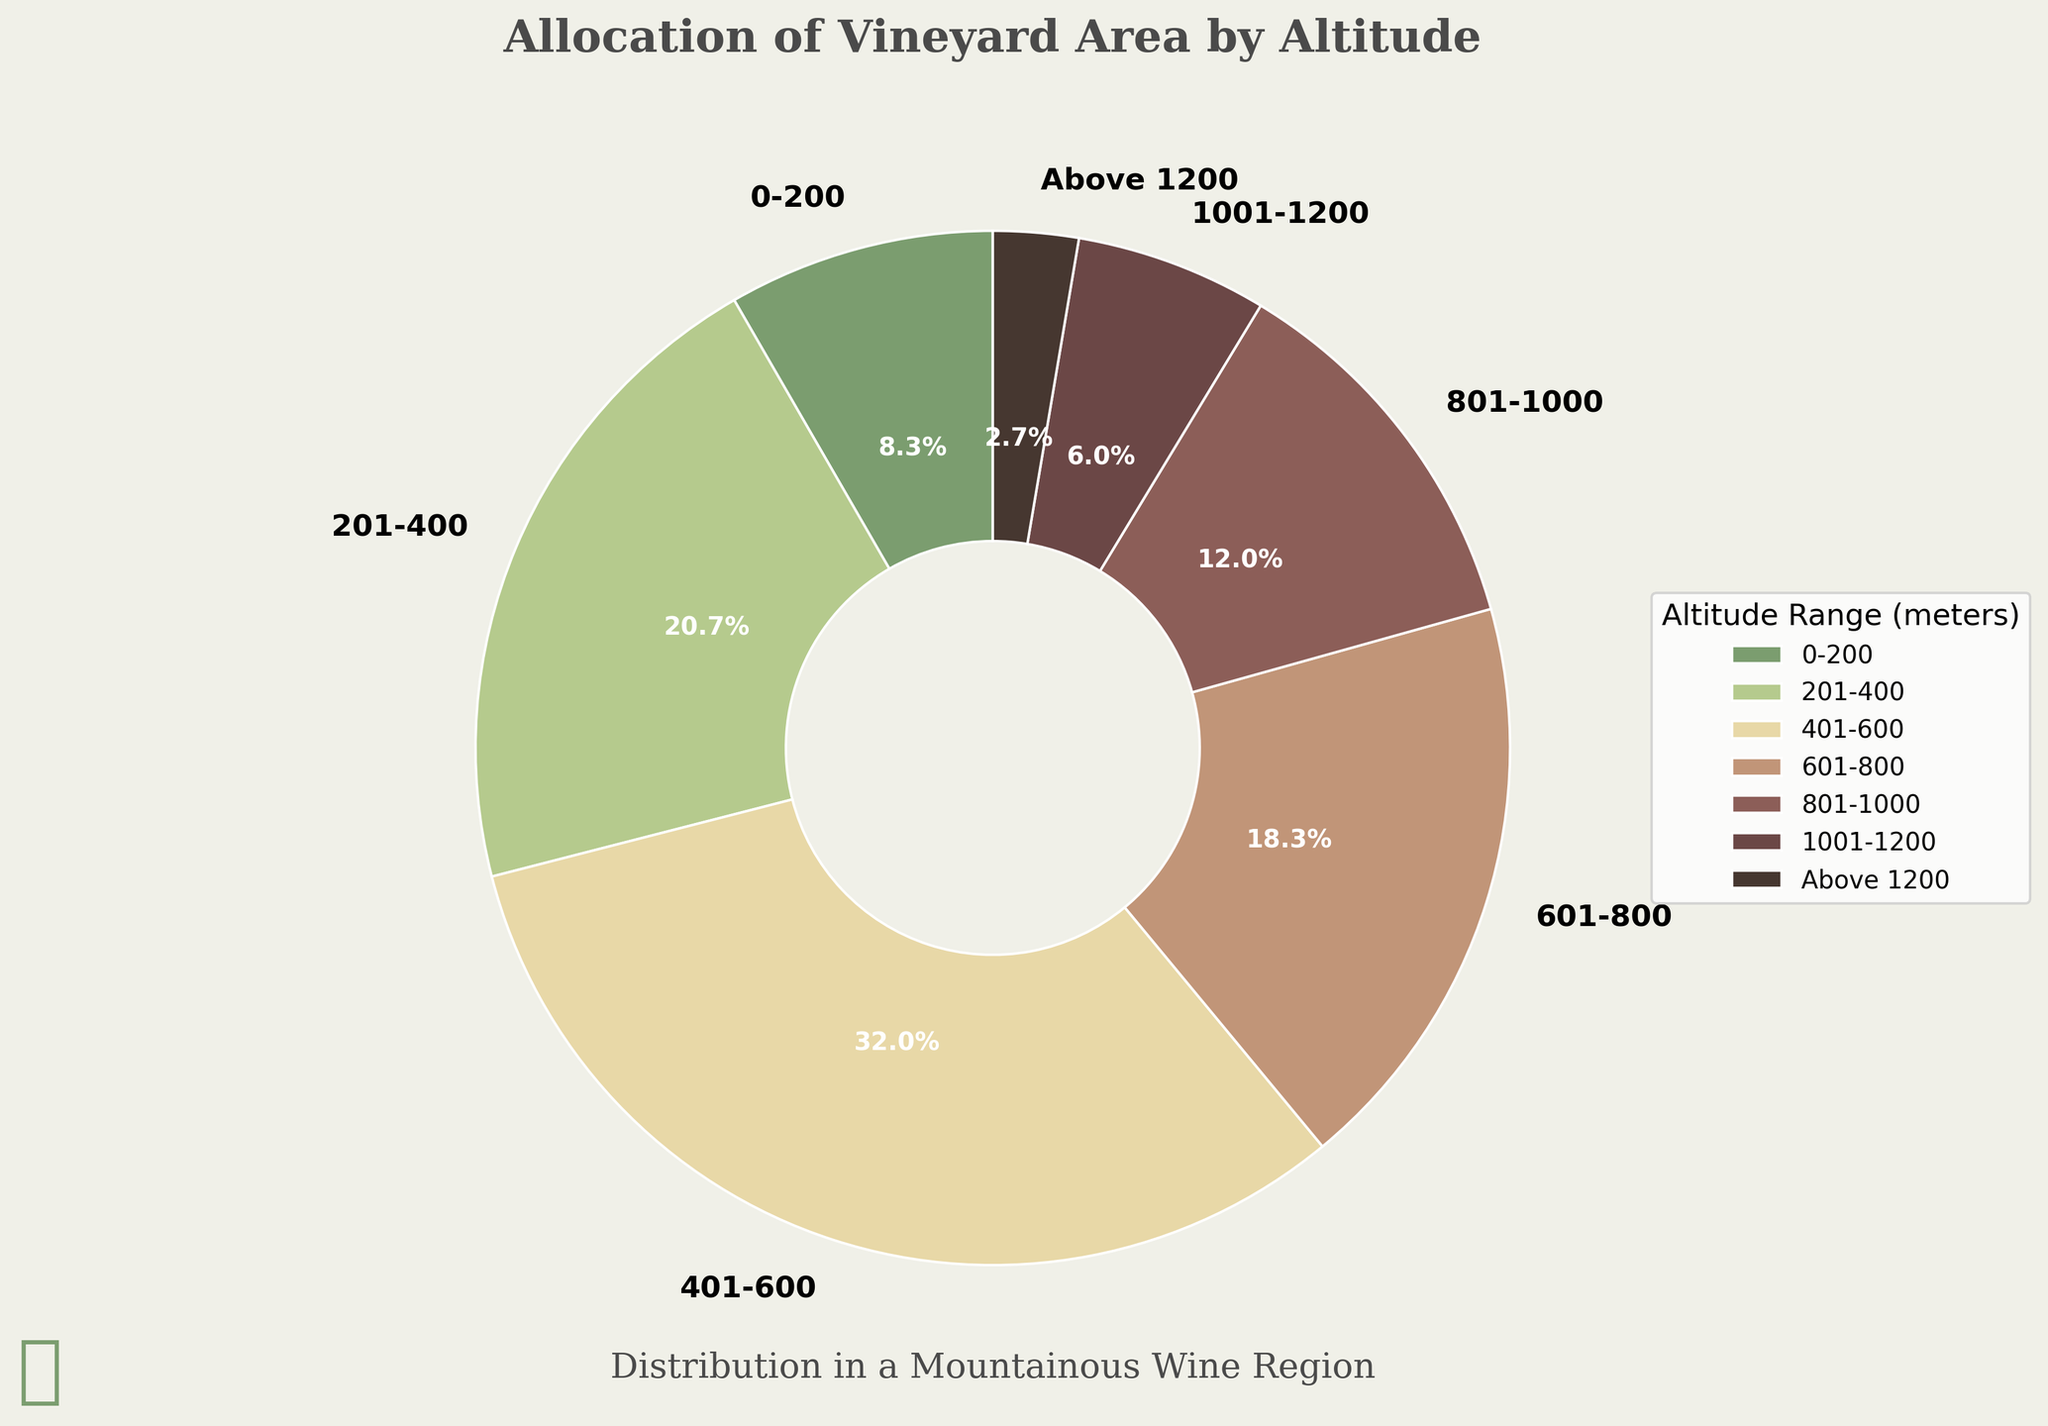What is the overall trend in the allocation of vineyard area by altitude? The trend shows that the vineyard area generally increases with altitude from 0-200 meters to 401-600 meters, reaching a peak at 401-600 meters, then gradually decreases as altitude increases beyond 600 meters. The largest area is between 401-600 meters while the smallest area is above 1200 meters.
Answer: The vineyard area initially increases with altitude, peaks at 401-600 meters, then decreases as altitude increases Which altitude range has the largest vineyard area? By inspecting the pie chart, the slice corresponding to the 401-600 meters altitude range is the largest indicating the highest vineyard area percentage. It is labeled with the percentage value.
Answer: 401-600 meters What percentage of the vineyard area is found above 1000 meters? From the chart, the segments for 1001-1200 meters and above 1200 meters are labeled with their percentage values: 8.4% and 3.8% respectively. Summing these gives 8.4% + 3.8%.
Answer: 12.2% How does the vineyard area between 601-800 meters compare to the area between 801-1000 meters? The pie chart shows that the 601-800 meters range has a larger slice compared to the 801-1000 meters range. Referring to their percentage labels, 601-800 meters is larger.
Answer: 601-800 meters is larger What is the combined vineyard area for altitudes up to 400 meters? Adding up the labeled percentages for 0-200 meters and 201-400 meters from the pie chart: 12% + 29.7%.
Answer: 41.7% Which altitude range occupies the smallest percentage of vineyard area? The smallest percentage slice in the pie chart is labeled for the "Above 1200 meters" range.
Answer: Above 1200 meters What's the ratio of vineyard area between 401-600 meters and 1001-1200 meters? From the pie chart, the percentages for these ranges are labeled as 45.9% for 401-600 meters and 8.4% for 1001-1200 meters. The ratio is 45.9% / 8.4%.
Answer: 5.46:1 How do the vineyard areas between altitudes 0-200 meters and 201-400 meters compare visually in the pie chart? Visually comparing the slices, the slice for 201-400 meters is noticeably larger than that of 0-200 meters. By checking the label percentages, 201-400 meters has 29.7%, which is substantially more than the 12% of 0-200 meters.
Answer: 201-400 meters is larger What percentage of vineyard area is found between 201-800 meters? Summing the labeled percentages for 201-400 meters, 401-600 meters, and 601-800 meters from the pie chart: 29.7% + 45.9% + 26.3% respectively.
Answer: 101.9% 